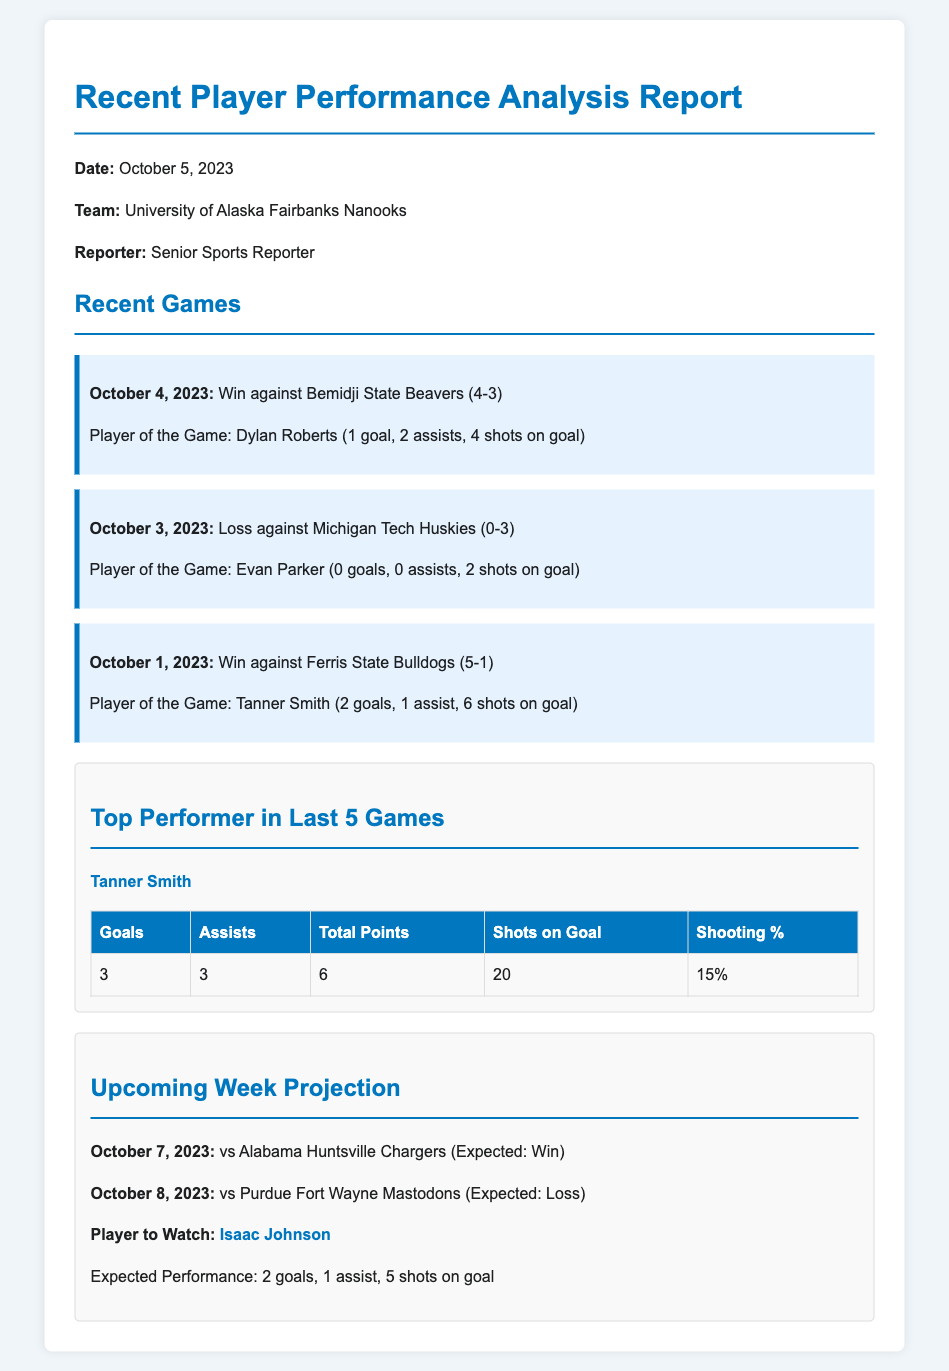What was the date of the most recent game? The date of the most recent game is mentioned as October 4, 2023.
Answer: October 4, 2023 Who was the player of the game in the win against Bemidji State Beavers? The document states that Dylan Roberts was the player of the game for this match.
Answer: Dylan Roberts How many assists did Tanner Smith achieve in the last 5 games? The statistics table shows that Tanner Smith had 3 assists in the last 5 games.
Answer: 3 What is the expected outcome for the game on October 8, 2023? The document indicates that the expected outcome for this game is a loss.
Answer: Loss What was Tanner Smith's shooting percentage in the last 5 games? The table in the statistics section specifies Tanner Smith's shooting percentage as 15%.
Answer: 15% How many goals is Isaac Johnson expected to score in the upcoming week? The projection section mentions that Isaac Johnson is expected to score 2 goals.
Answer: 2 What was the score of the game against Michigan Tech Huskies? The document provides the score of this game as 0-3.
Answer: 0-3 What is the title of the document? The title of the document is prominently displayed at the top as "Recent Player Performance Analysis Report."
Answer: Recent Player Performance Analysis Report 